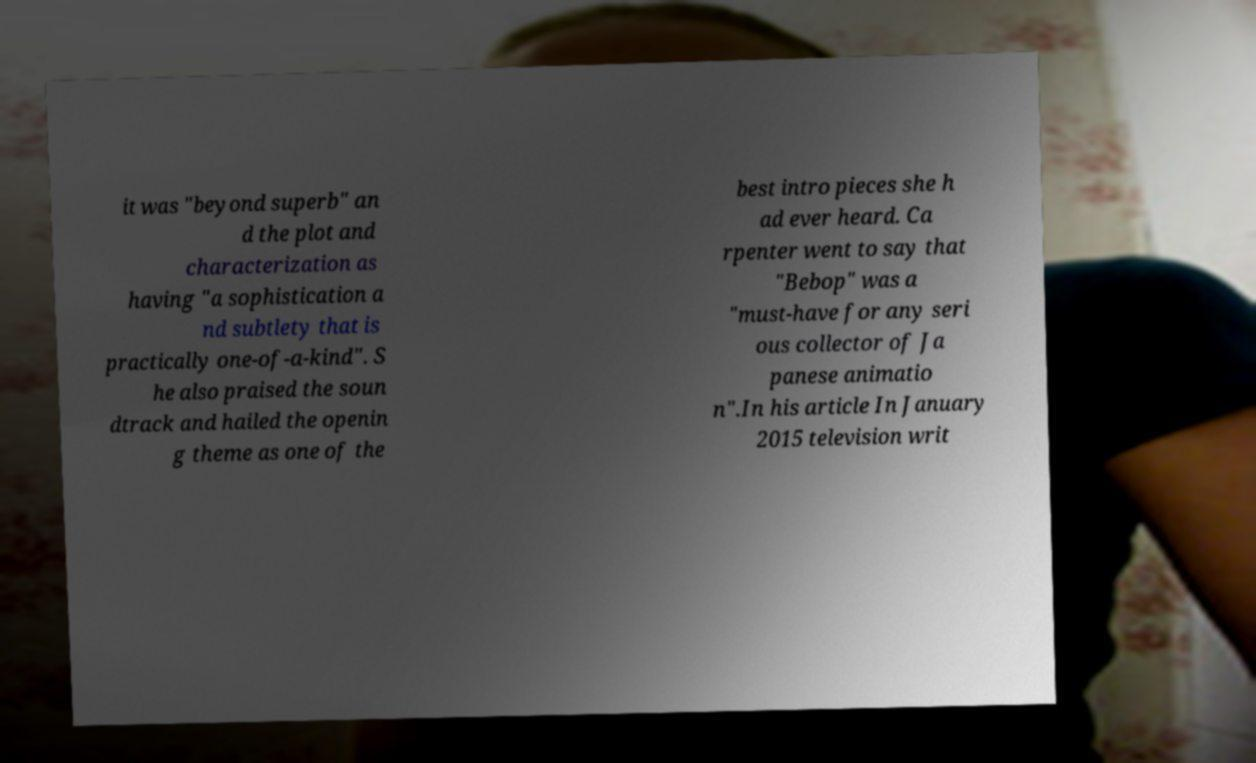Can you read and provide the text displayed in the image?This photo seems to have some interesting text. Can you extract and type it out for me? it was "beyond superb" an d the plot and characterization as having "a sophistication a nd subtlety that is practically one-of-a-kind". S he also praised the soun dtrack and hailed the openin g theme as one of the best intro pieces she h ad ever heard. Ca rpenter went to say that "Bebop" was a "must-have for any seri ous collector of Ja panese animatio n".In his article In January 2015 television writ 